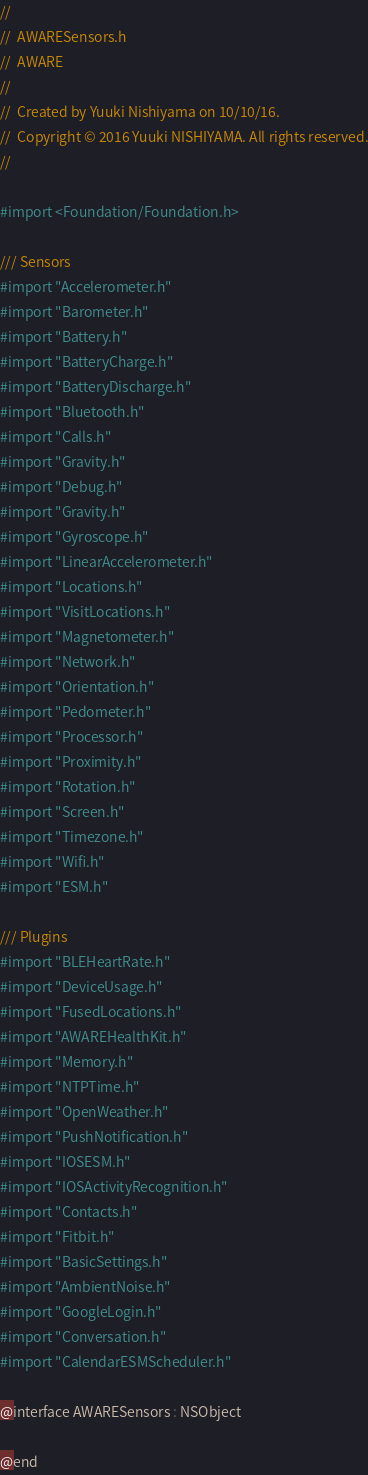Convert code to text. <code><loc_0><loc_0><loc_500><loc_500><_C_>//
//  AWARESensors.h
//  AWARE
//
//  Created by Yuuki Nishiyama on 10/10/16.
//  Copyright © 2016 Yuuki NISHIYAMA. All rights reserved.
//

#import <Foundation/Foundation.h>

/// Sensors
#import "Accelerometer.h"
#import "Barometer.h"
#import "Battery.h"
#import "BatteryCharge.h"
#import "BatteryDischarge.h"
#import "Bluetooth.h"
#import "Calls.h"
#import "Gravity.h"
#import "Debug.h"
#import "Gravity.h"
#import "Gyroscope.h"
#import "LinearAccelerometer.h"
#import "Locations.h"
#import "VisitLocations.h"
#import "Magnetometer.h"
#import "Network.h"
#import "Orientation.h"
#import "Pedometer.h"
#import "Processor.h"
#import "Proximity.h"
#import "Rotation.h"
#import "Screen.h"
#import "Timezone.h"
#import "Wifi.h"
#import "ESM.h"

/// Plugins
#import "BLEHeartRate.h"
#import "DeviceUsage.h"
#import "FusedLocations.h"
#import "AWAREHealthKit.h"
#import "Memory.h"
#import "NTPTime.h"
#import "OpenWeather.h"
#import "PushNotification.h"
#import "IOSESM.h"
#import "IOSActivityRecognition.h"
#import "Contacts.h"
#import "Fitbit.h"
#import "BasicSettings.h"
#import "AmbientNoise.h"
#import "GoogleLogin.h"
#import "Conversation.h"
#import "CalendarESMScheduler.h"

@interface AWARESensors : NSObject

@end
</code> 